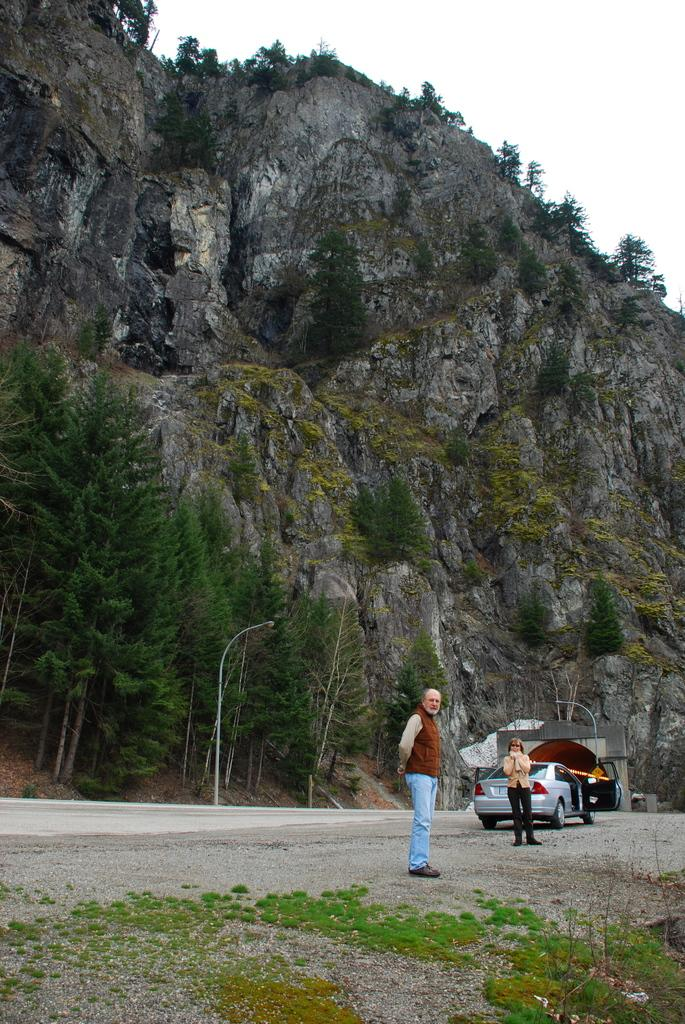What is the main subject of the image? There is a car in the image. How many people are present in the image? There are two persons in the image. What type of natural environment can be seen in the image? There is grass, a mountain, trees, and the sky visible in the image. What type of beef is being served at the scene in the image? There is no scene or beef present in the image; it features a car and two people in a natural environment. Can you tell me the color of the badge on the car in the image? There is no badge visible on the car in the image. 